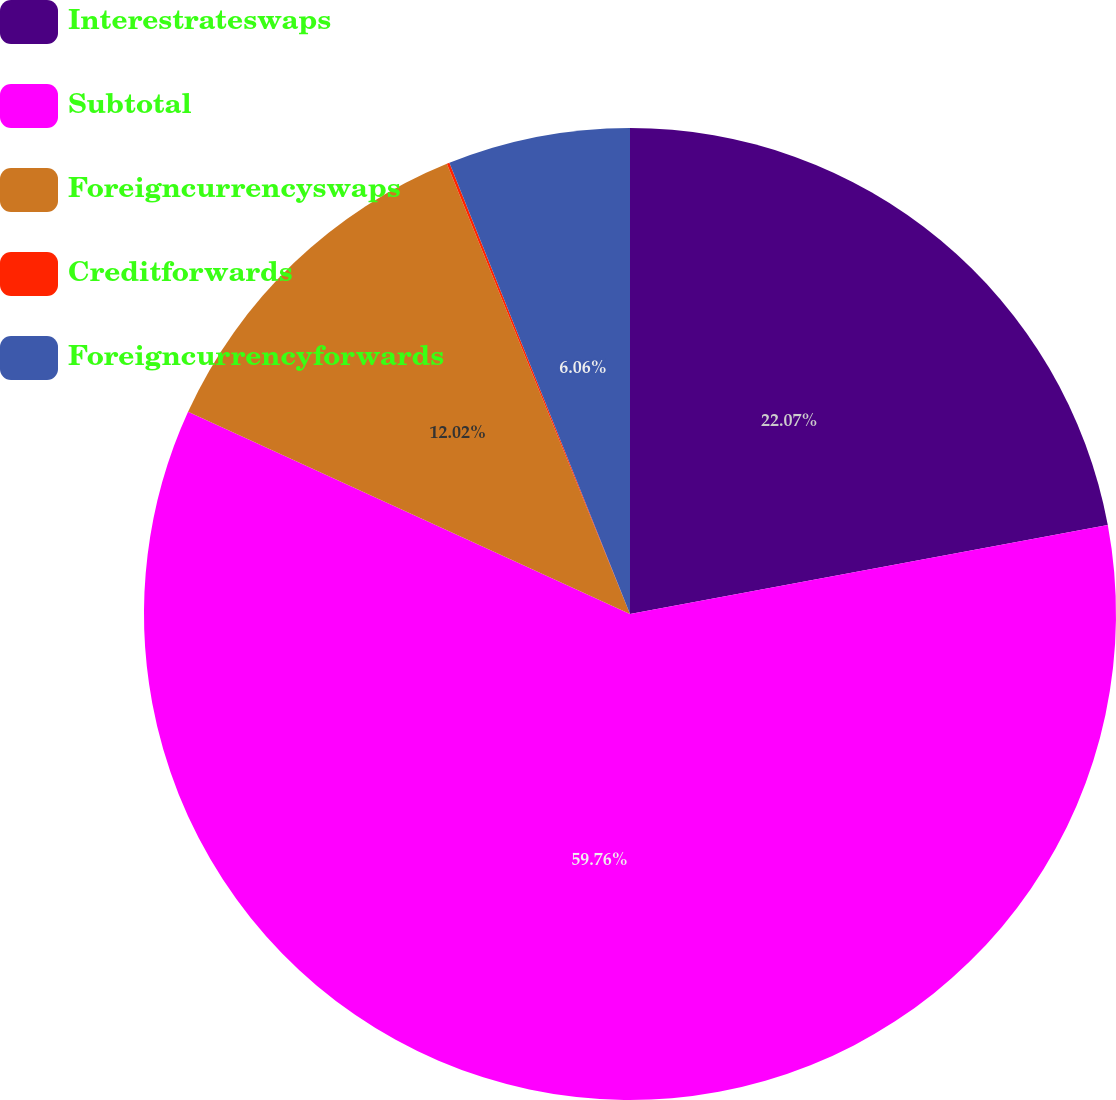<chart> <loc_0><loc_0><loc_500><loc_500><pie_chart><fcel>Interestrateswaps<fcel>Subtotal<fcel>Foreigncurrencyswaps<fcel>Creditforwards<fcel>Foreigncurrencyforwards<nl><fcel>22.07%<fcel>59.76%<fcel>12.02%<fcel>0.09%<fcel>6.06%<nl></chart> 